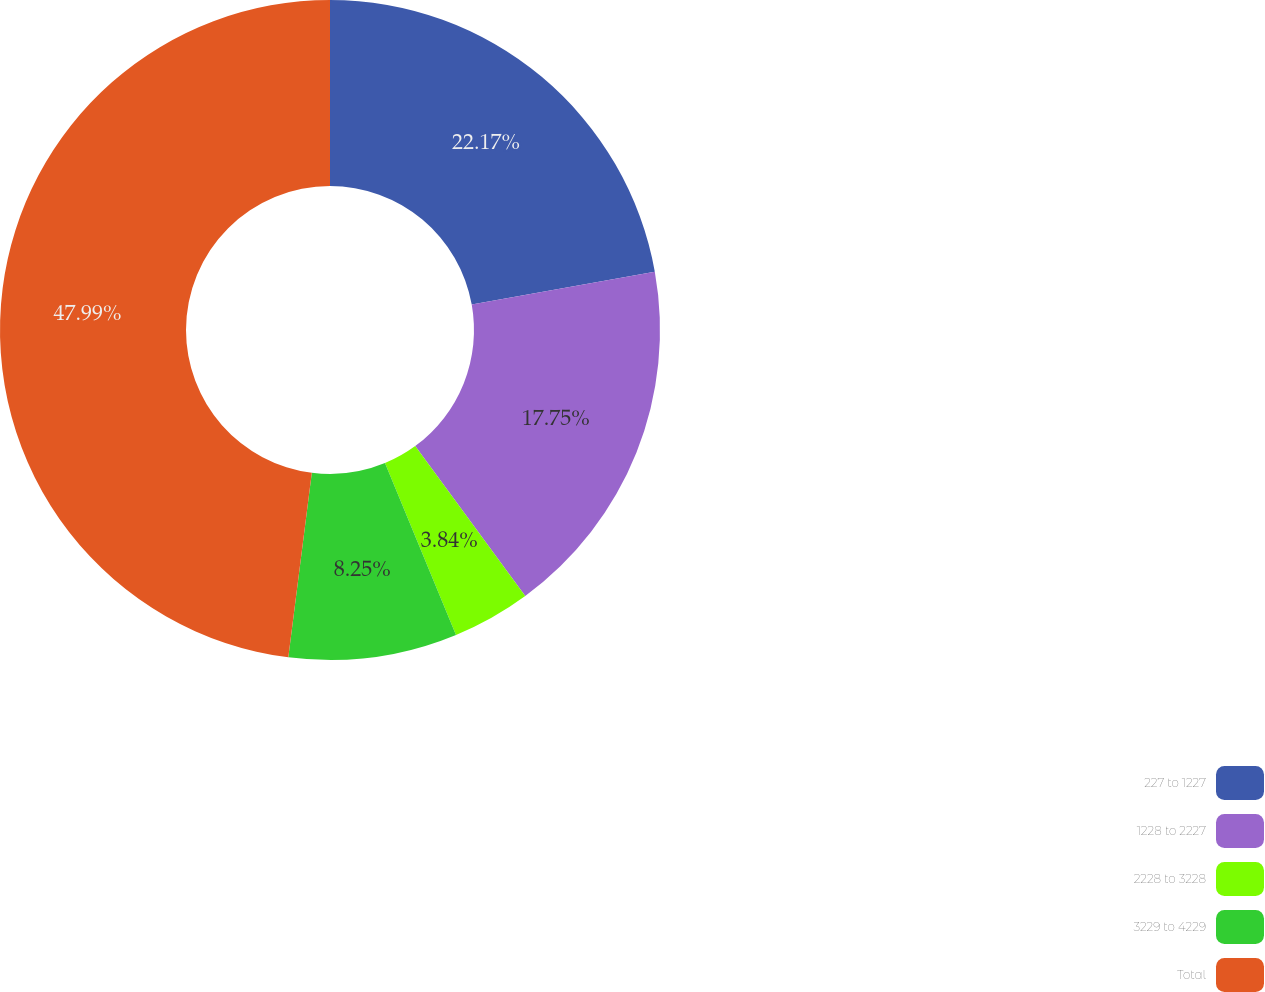Convert chart. <chart><loc_0><loc_0><loc_500><loc_500><pie_chart><fcel>227 to 1227<fcel>1228 to 2227<fcel>2228 to 3228<fcel>3229 to 4229<fcel>Total<nl><fcel>22.17%<fcel>17.75%<fcel>3.84%<fcel>8.25%<fcel>47.98%<nl></chart> 